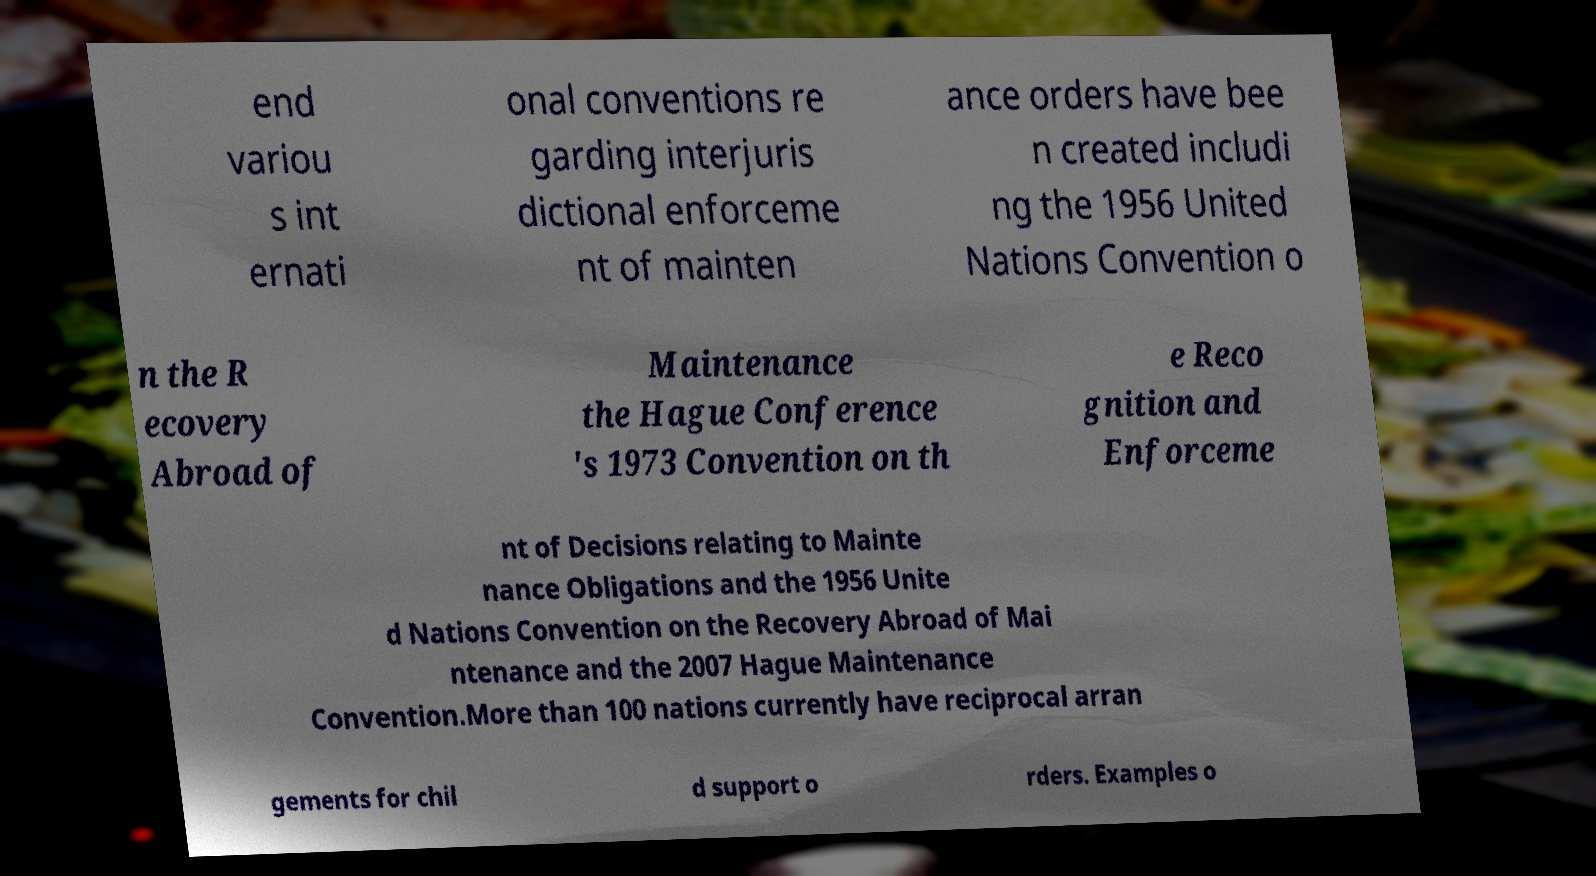Please identify and transcribe the text found in this image. end variou s int ernati onal conventions re garding interjuris dictional enforceme nt of mainten ance orders have bee n created includi ng the 1956 United Nations Convention o n the R ecovery Abroad of Maintenance the Hague Conference 's 1973 Convention on th e Reco gnition and Enforceme nt of Decisions relating to Mainte nance Obligations and the 1956 Unite d Nations Convention on the Recovery Abroad of Mai ntenance and the 2007 Hague Maintenance Convention.More than 100 nations currently have reciprocal arran gements for chil d support o rders. Examples o 